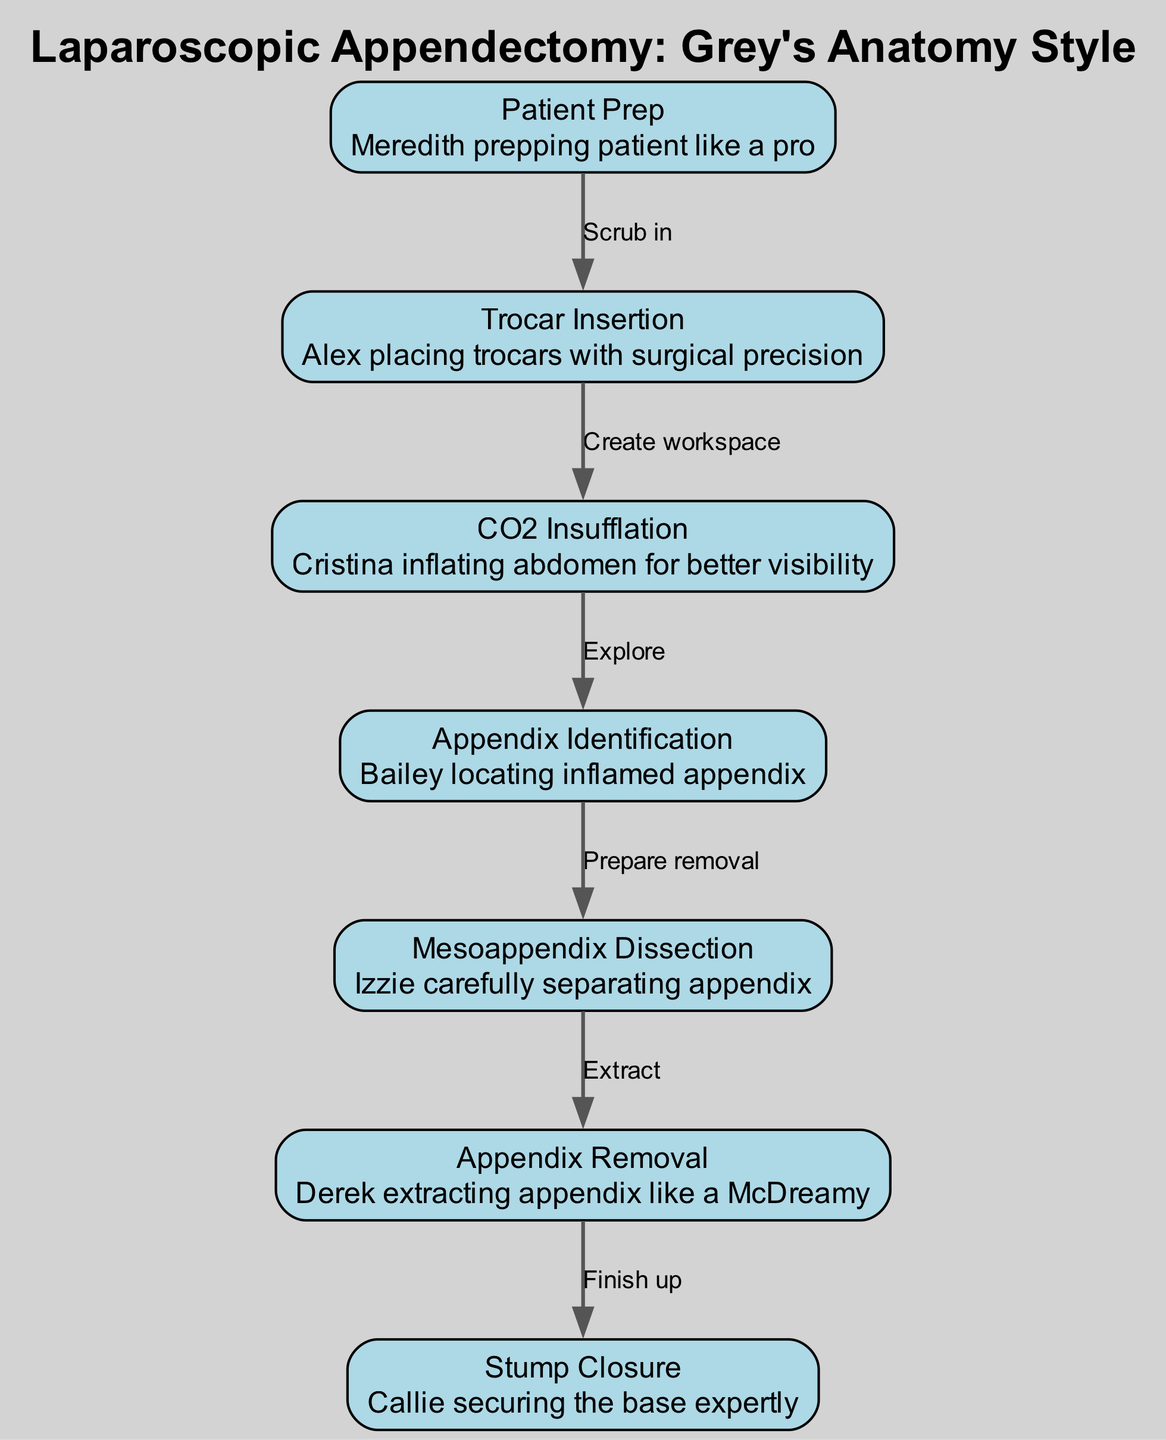What is the first step in the procedure? The first node in the diagram is "Patient Prep," indicating that this is the initial step before any surgical actions are taken.
Answer: Patient Prep How many nodes are in the diagram? The diagram contains seven nodes, each corresponding to a specific step in the laparoscopic appendectomy process.
Answer: 7 Which node follows "Trocar Insertion"? Following "Trocar Insertion," the diagram shows "CO2 Insufflation," indicating the next step after inserting the trocars.
Answer: CO2 Insufflation What is the relationship between "Appendix Identification" and "Mesoappendix Dissection"? "Appendix Identification" is directly followed by "Mesoappendix Dissection," meaning that after identifying the appendix, the surgeon prepares to dissect it.
Answer: Prepare removal What is the last step shown in the diagram? The last node in the diagram is "Stump Closure," which completes the surgical procedure after the appendix removal.
Answer: Stump Closure During which step is the abdomen inflated? The step where the abdomen is inflated is "CO2 Insufflation," as indicated in the diagram.
Answer: CO2 Insufflation How many edges connect the nodes in this diagram? There are six edges connecting the nodes, representing the flow from one surgical step to the next in the procedure.
Answer: 6 What is the role of Callie in this procedure? Callie is responsible for "securing the base expertly," which refers to the Stump Closure step after the appendix is removed.
Answer: Stump Closure Which character is depicted as extracting the appendix? Derek is depicted as extracting the appendix in the diagram, indicated in the "Appendix Removal" step.
Answer: Derek 